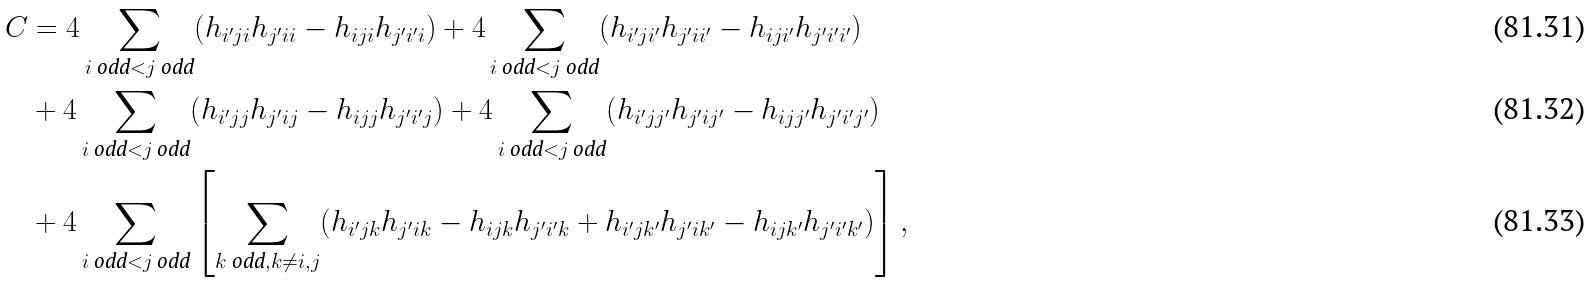<formula> <loc_0><loc_0><loc_500><loc_500>C & = 4 \sum _ { i \text { odd} < j \text { odd} } ( h _ { i ^ { \prime } j i } h _ { j ^ { \prime } i i } - h _ { i j i } h _ { j ^ { \prime } i ^ { \prime } i } ) + 4 \sum _ { i \text { odd} < j \text { odd} } ( h _ { i ^ { \prime } j i ^ { \prime } } h _ { j ^ { \prime } i i ^ { \prime } } - h _ { i j i ^ { \prime } } h _ { j ^ { \prime } i ^ { \prime } i ^ { \prime } } ) \\ & + 4 \sum _ { i \text { odd} < j \text { odd} } ( h _ { i ^ { \prime } j j } h _ { j ^ { \prime } i j } - h _ { i j j } h _ { j ^ { \prime } i ^ { \prime } j } ) + 4 \sum _ { i \text { odd} < j \text { odd} } ( h _ { i ^ { \prime } j j ^ { \prime } } h _ { j ^ { \prime } i j ^ { \prime } } - h _ { i j j ^ { \prime } } h _ { j ^ { \prime } i ^ { \prime } j ^ { \prime } } ) \\ & + 4 \sum _ { i \text { odd} < j \text { odd} } \left [ \sum _ { k \text { odd} , k \not = i , j } ( h _ { i ^ { \prime } j k } h _ { j ^ { \prime } i k } - h _ { i j k } h _ { j ^ { \prime } i ^ { \prime } k } + h _ { i ^ { \prime } j k ^ { \prime } } h _ { j ^ { \prime } i k ^ { \prime } } - h _ { i j k ^ { \prime } } h _ { j ^ { \prime } i ^ { \prime } k ^ { \prime } } ) \right ] ,</formula> 